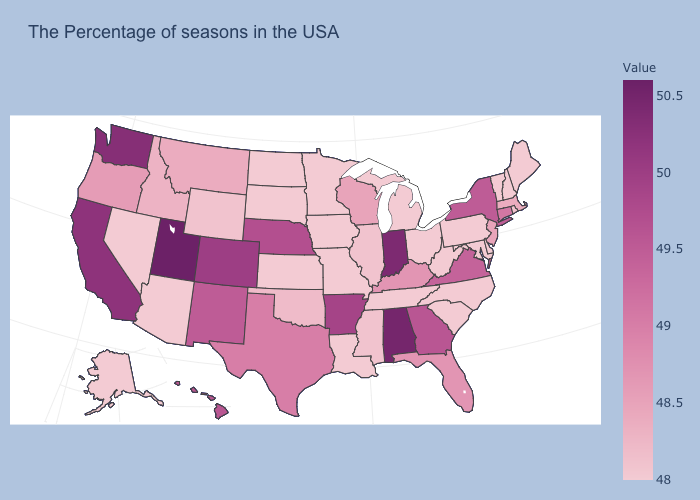Does Rhode Island have the lowest value in the USA?
Be succinct. No. Does South Carolina have a lower value than New Jersey?
Short answer required. Yes. Does Pennsylvania have the lowest value in the USA?
Give a very brief answer. Yes. Does New York have the highest value in the Northeast?
Give a very brief answer. Yes. Does Hawaii have the lowest value in the USA?
Short answer required. No. 